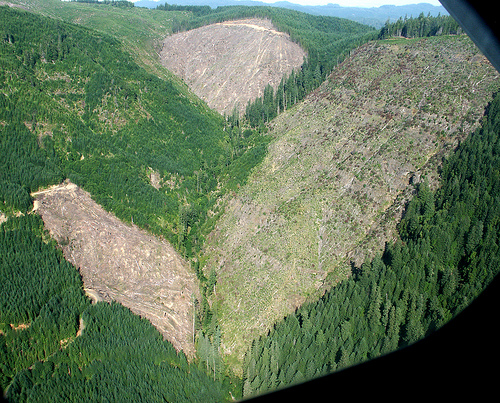<image>
Can you confirm if the mountain is above the trees? No. The mountain is not positioned above the trees. The vertical arrangement shows a different relationship. 